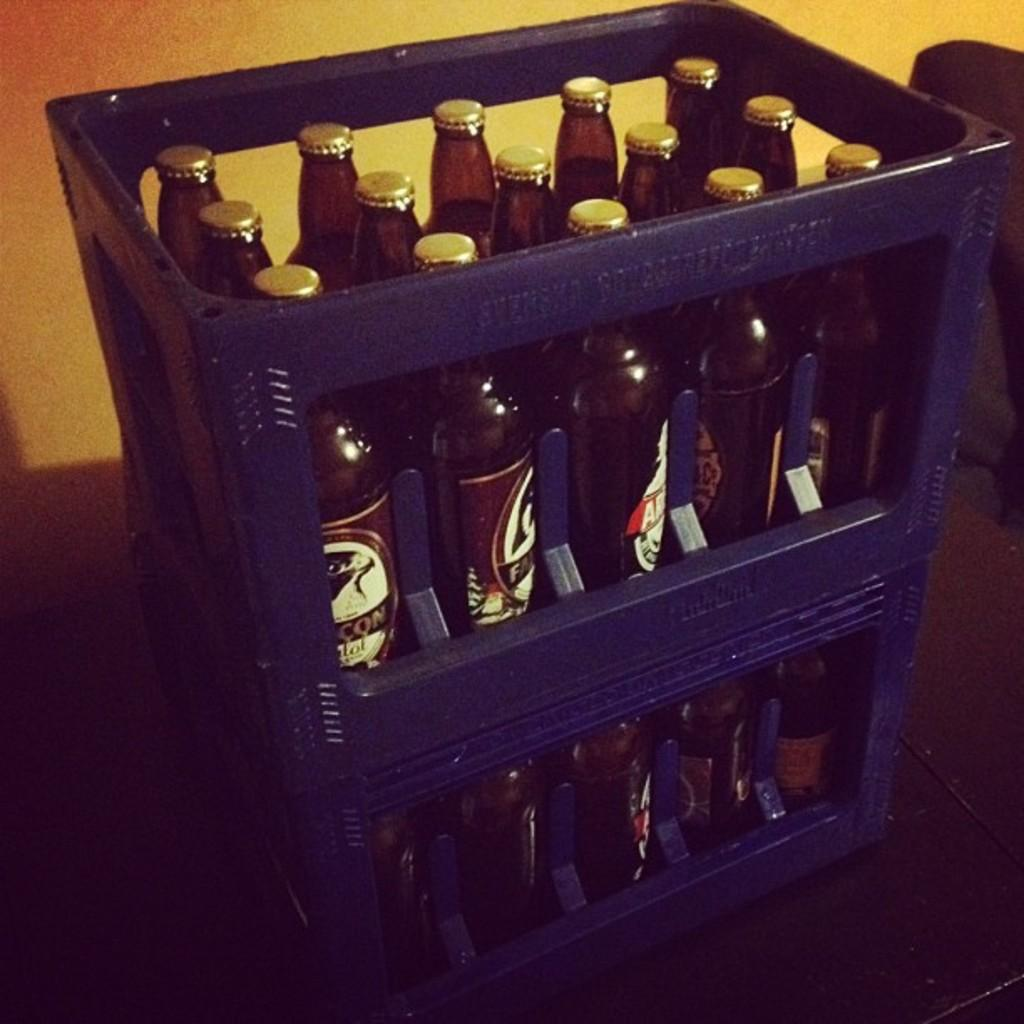How many laborers can be seen shaking hands in the image? There is no image provided, so it is impossible to determine the presence or actions of any laborers. 